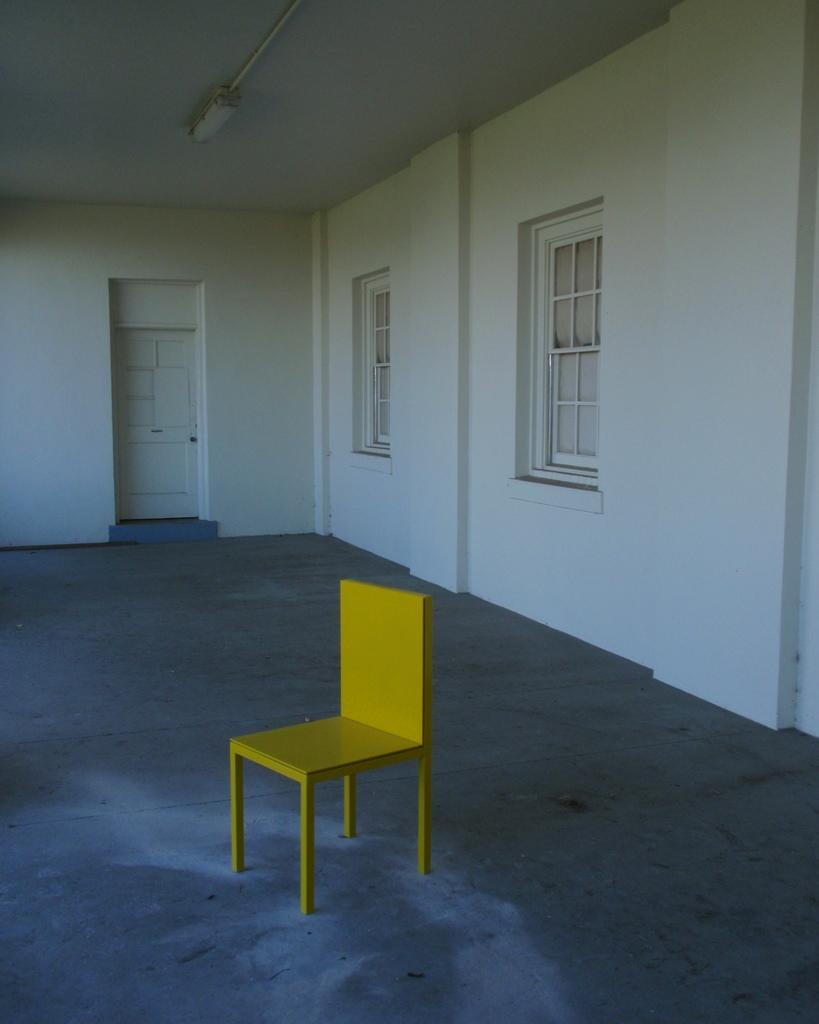What is located in the foreground of the image? There is a chair in the foreground of the image. Where is the chair positioned in relation to the floor? The chair is on the floor. What can be seen in the background of the image? There is a wall, a door, and windows in the background of the image. Is there any source of light visible in the image? Yes, there is a light visible in the image. What type of space is depicted in the image? The image is taken in a hall. What is the chair writing in the image? Chairs do not have the ability to write, so there is no writing activity taking place in the image. 